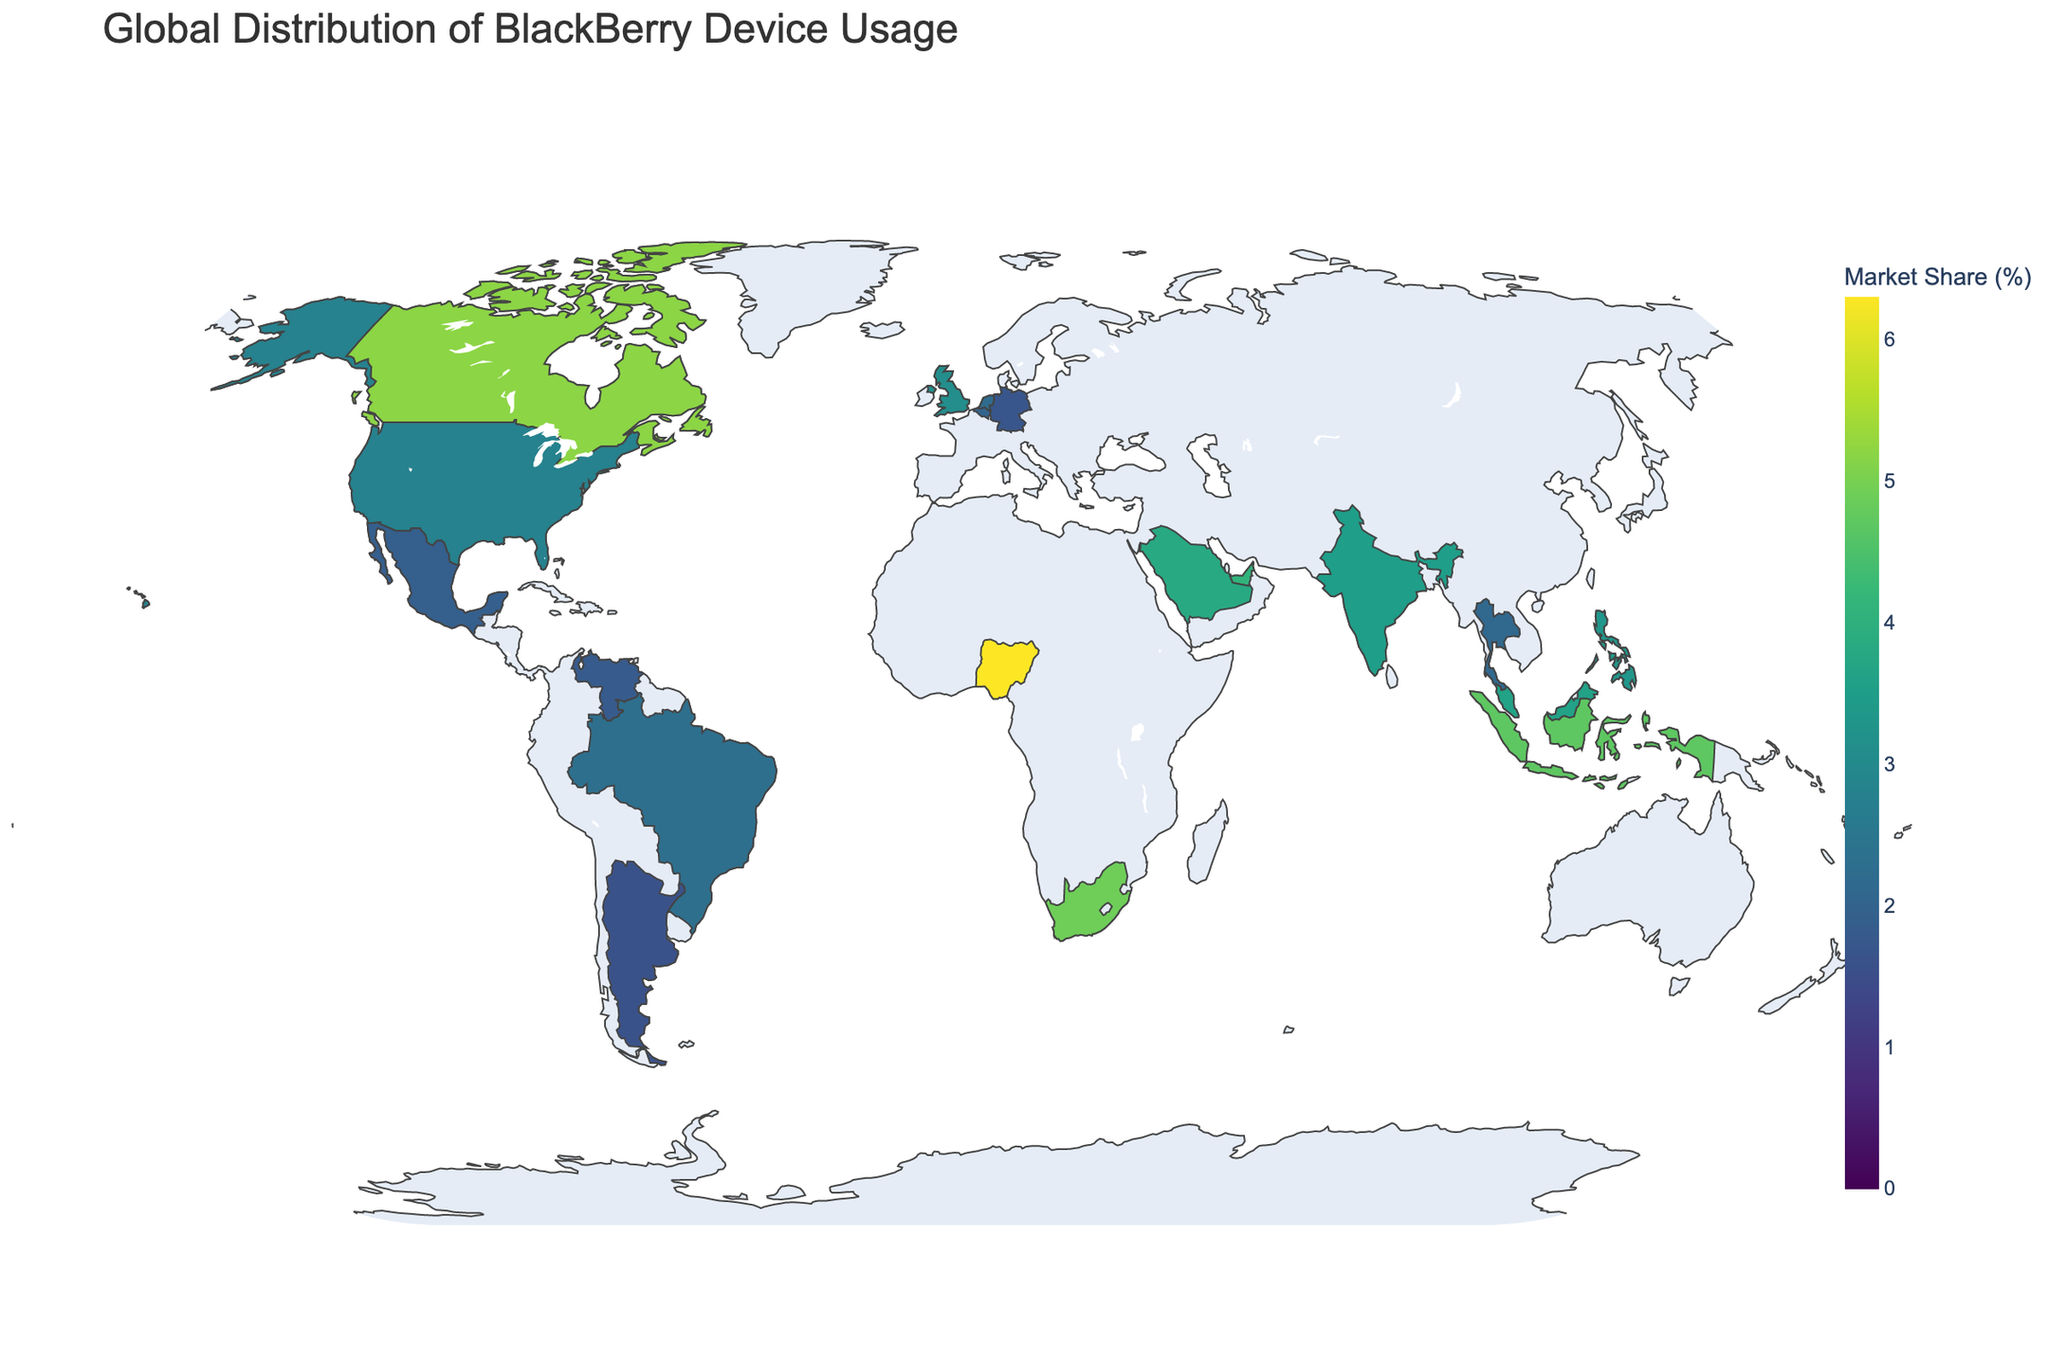What's the title of the figure? The title is placed prominently at the top of the figure and reads "Global Distribution of BlackBerry Device Usage."
Answer: Global Distribution of BlackBerry Device Usage Which country has the highest market share percentage for BlackBerry devices? By examining the color intensity and hover information on the map, Nigeria appears to have the highest BlackBerry market share percentage.
Answer: Nigeria How does the market share percentage of BlackBerry devices in the United States compare to that in Canada? The figure shows that the United States has a 2.8% market share, while Canada has a 5.2% market share. The comparison indicates that Canada has a higher market share percentage than the United States.
Answer: Canada has a higher market share than the United States What is the average market share percentage for the countries shown? To find the average, sum up all the market share percentages and divide by the number of countries. The sum is 60.4% and there are 20 countries, so the average is 60.4 / 20.
Answer: 3.02% Which country has the closest market share percentage to the global average? Using the calculated average of 3.02%, we find that the Philippines with 3.3% is closest to this value among all the countries.
Answer: Philippines What is the range of BlackBerry market share percentages represented in the figure? The highest market share percentage is 6.3% (Nigeria) and the lowest is 1.6% (Argentina). The range is the difference between these values.
Answer: 4.7% Identify countries that have a market share greater than 4%. By inspecting the coloration and the hover text, countries with a market share greater than 4% are Canada, Indonesia, Nigeria, South Africa, United Arab Emirates, and Saudi Arabia.
Answer: Canada, Indonesia, Nigeria, South Africa, United Arab Emirates, Saudi Arabia How many countries have a market share percentage below 2%? By identifying the countries in the figure with percentages under 2%, we find Mexico, Germany, Venezuela, and Argentina, which amounts to four countries.
Answer: 4 Compare the market share of BlackBerry devices in Europe to that in Africa. Which continent has higher usage? The European countries shown are the United Kingdom, Germany, Netherlands, and Belgium. Their market shares are 3.1%, 1.7%, 2.2%, and 2.0%, respectively. The African countries shown are Nigeria and South Africa, with 6.3% and 4.9% market shares. Summing up: Europe = 9%, Africa = 11.2%. Africa has a higher usage.
Answer: Africa What's the combined market share percentage of BlackBerry devices in Southeast Asia (Philippines, Malaysia, Singapore, Thailand)? Adding market shares for Philippines (3.3%), Malaysia (3.6%), Singapore (2.5%), and Thailand (2.1%) gives a total of 11.5%.
Answer: 11.5% 